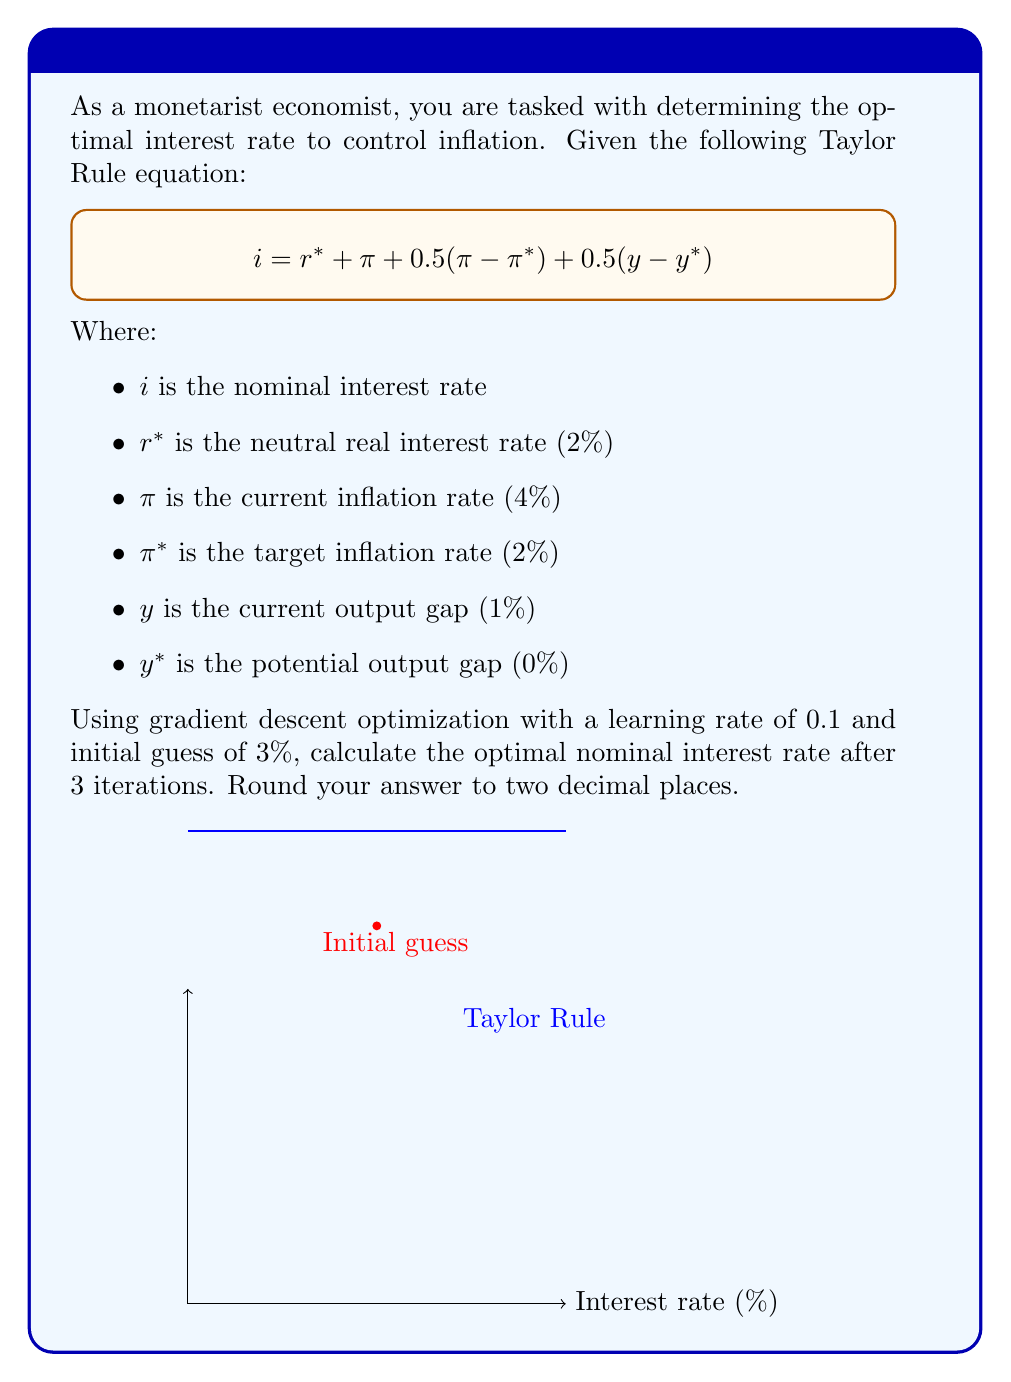Can you answer this question? Let's approach this step-by-step using gradient descent:

1) First, we need to define our objective function. The Taylor Rule is:

   $$ i = r^* + \pi + 0.5(\pi - \pi^*) + 0.5(y - y^*) $$

   Substituting the given values:

   $$ i = 2 + 4 + 0.5(4 - 2) + 0.5(1 - 0) = 7.5 $$

2) Our goal is to minimize the difference between our guess and this target value. Let's call our guess $x$. Our objective function is:

   $$ f(x) = (x - 7.5)^2 $$

3) The derivative of this function is:

   $$ f'(x) = 2(x - 7.5) $$

4) Now, let's perform gradient descent. The update rule is:

   $$ x_{new} = x_{old} - \text{learning_rate} * f'(x_{old}) $$

5) Starting with $x_0 = 3$ and learning rate $\alpha = 0.1$:

   Iteration 1:
   $x_1 = 3 - 0.1 * 2(3 - 7.5) = 3 - 0.1 * (-9) = 3.9$

   Iteration 2:
   $x_2 = 3.9 - 0.1 * 2(3.9 - 7.5) = 3.9 - 0.1 * (-7.2) = 4.62$

   Iteration 3:
   $x_3 = 4.62 - 0.1 * 2(4.62 - 7.5) = 4.62 - 0.1 * (-5.76) = 5.196$

6) Rounding to two decimal places, we get 5.20.
Answer: 5.20% 